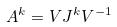<formula> <loc_0><loc_0><loc_500><loc_500>A ^ { k } = V J ^ { k } V ^ { - 1 }</formula> 